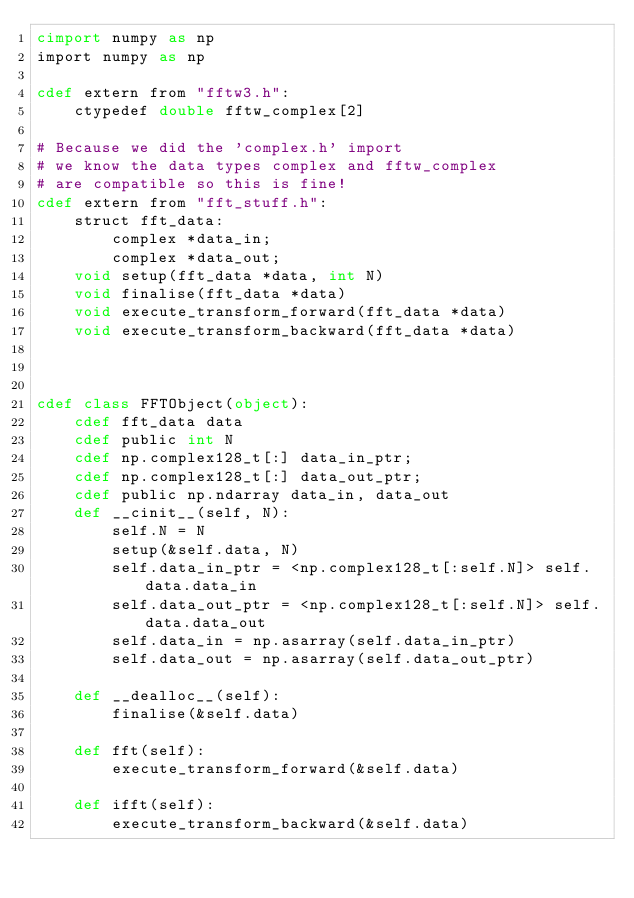<code> <loc_0><loc_0><loc_500><loc_500><_Cython_>cimport numpy as np
import numpy as np

cdef extern from "fftw3.h":
    ctypedef double fftw_complex[2]

# Because we did the 'complex.h' import 
# we know the data types complex and fftw_complex
# are compatible so this is fine!
cdef extern from "fft_stuff.h":
    struct fft_data:
        complex *data_in;
        complex *data_out;
    void setup(fft_data *data, int N)
    void finalise(fft_data *data)
    void execute_transform_forward(fft_data *data)
    void execute_transform_backward(fft_data *data)


        
cdef class FFTObject(object):
    cdef fft_data data
    cdef public int N
    cdef np.complex128_t[:] data_in_ptr;
    cdef np.complex128_t[:] data_out_ptr;
    cdef public np.ndarray data_in, data_out
    def __cinit__(self, N):
        self.N = N
        setup(&self.data, N)
        self.data_in_ptr = <np.complex128_t[:self.N]> self.data.data_in
        self.data_out_ptr = <np.complex128_t[:self.N]> self.data.data_out
        self.data_in = np.asarray(self.data_in_ptr)
        self.data_out = np.asarray(self.data_out_ptr)

    def __dealloc__(self):
        finalise(&self.data)

    def fft(self):
        execute_transform_forward(&self.data)

    def ifft(self):
        execute_transform_backward(&self.data)

</code> 